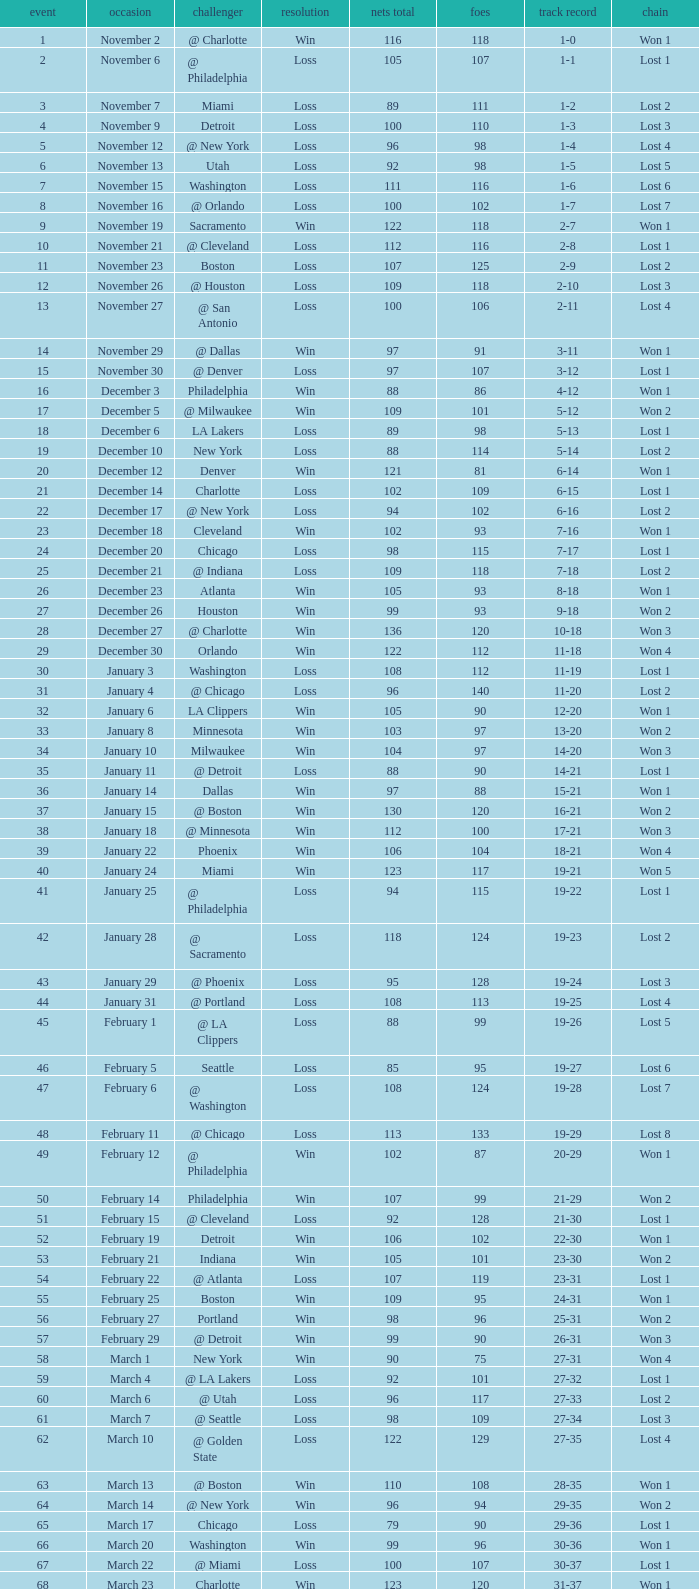How many games had fewer than 118 opponents and more than 109 net points with an opponent of Washington? 1.0. 